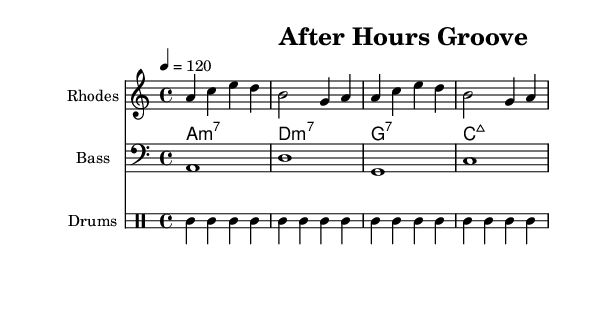What is the key signature of this music? The key signature shows there is one flat, indicating that the key is A minor (or C major). A minor has no sharps or flats but is represented as having no sharps or flats.
Answer: A minor What is the time signature of this music? The time signature is indicated at the beginning of the score, where it shows 4/4, meaning there are four beats in each measure.
Answer: 4/4 What is the tempo marking for this piece? The tempo marking given shows a quarter note equals 120 beats per minute, which indicates a moderate tempo.
Answer: 120 How many measures are in the Rhodes part? Upon counting the measures in the Rhodes part, there are a total of 8 measures present in the score.
Answer: 8 What type of chords are used in the chord progression? The chord names indicate various types of seventh chords, specifically minor seventh and major seventh chords.
Answer: Minor 7th, Major 7th What is the pattern of the bass notes? The bass notes follow a simple root progression, moving from A to D, to G, and then to C, which corresponds to the chords used in the piece.
Answer: A, D, G, C How does the drum pattern relate to the house genre? The drum pattern features typical house beats, with a strong bass drum on the downbeats and consistent hi-hat on the offbeats, creating a driving rhythm.
Answer: Driving rhythm 